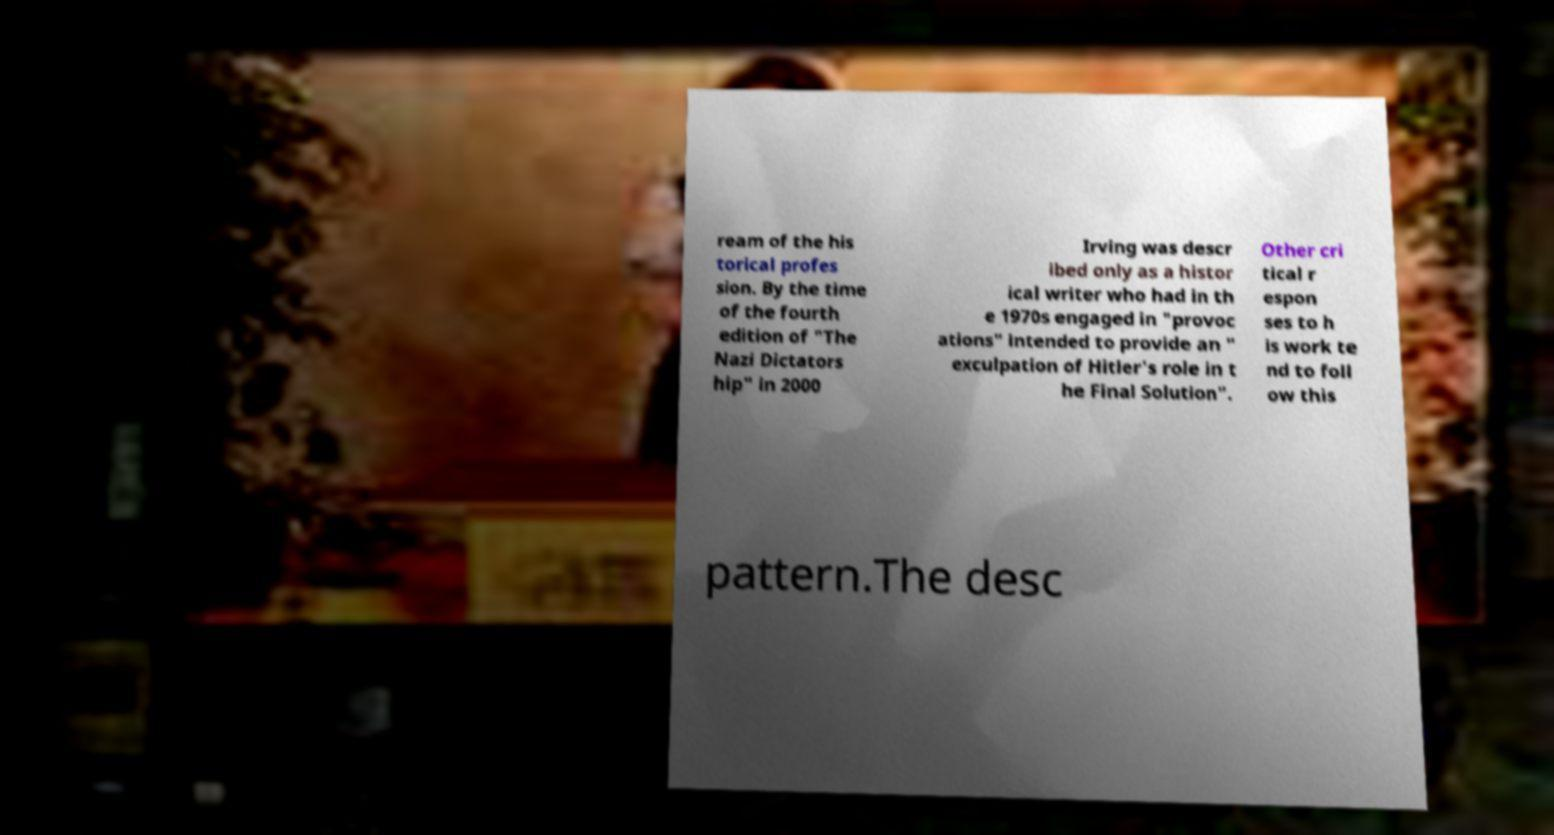Could you extract and type out the text from this image? ream of the his torical profes sion. By the time of the fourth edition of "The Nazi Dictators hip" in 2000 Irving was descr ibed only as a histor ical writer who had in th e 1970s engaged in "provoc ations" intended to provide an " exculpation of Hitler's role in t he Final Solution". Other cri tical r espon ses to h is work te nd to foll ow this pattern.The desc 